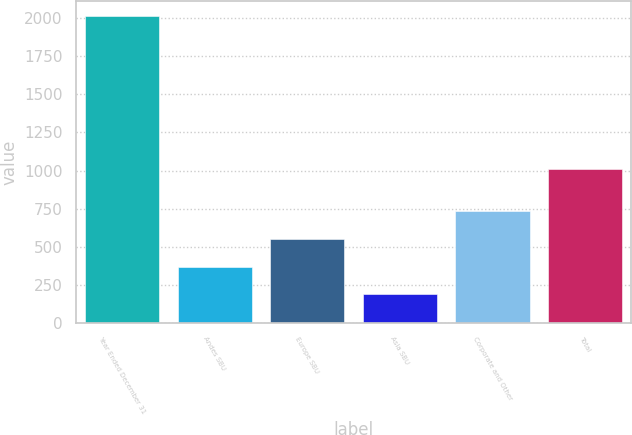Convert chart to OTSL. <chart><loc_0><loc_0><loc_500><loc_500><bar_chart><fcel>Year Ended December 31<fcel>Andes SBU<fcel>Europe SBU<fcel>Asia SBU<fcel>Corporate and Other<fcel>Total<nl><fcel>2013<fcel>368.7<fcel>551.4<fcel>186<fcel>734.1<fcel>1010<nl></chart> 